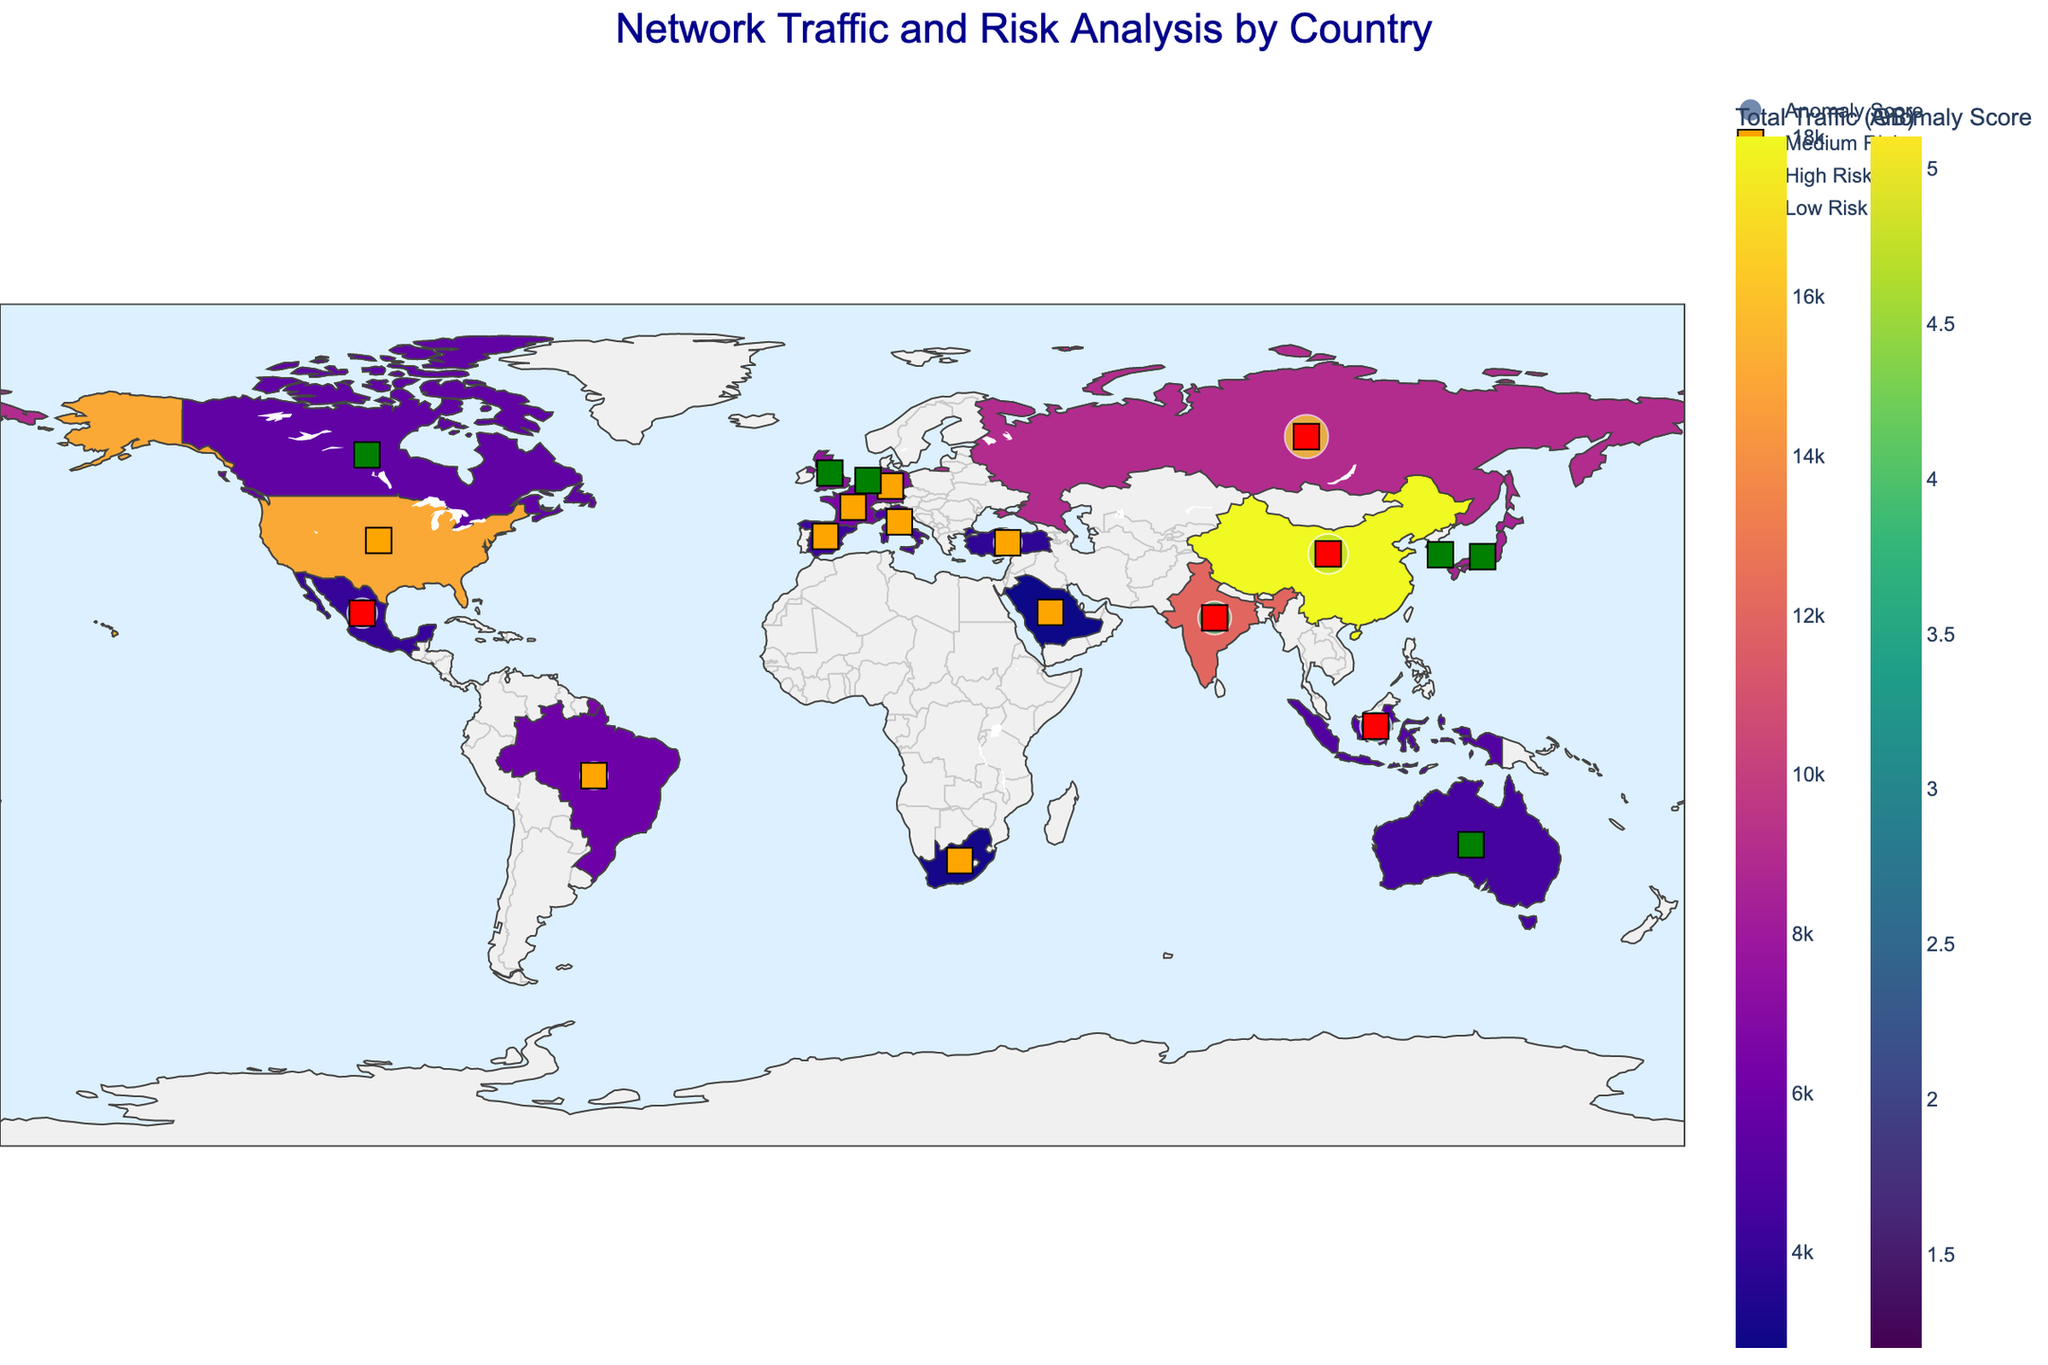What is the title of the figure? The title is typically found at the top of the figure, identifying the contents or purpose of the visual representation. In this case, the title is clearly displayed in dark blue at the center top of the figure.
Answer: Network Traffic and Risk Analysis by Country Which country has the highest total network traffic in GB? By examining the color intensity on the choropleth map, the country with the highest total network traffic will have the most intense color. Additionally, the hover data can confirm the exact traffic amount.
Answer: China What are the different risk levels represented in the figure? The legend at the bottom of the figure indicates the different risk levels by color. Squares in green, orange, and red represent low, medium, and high-risk levels respectively.
Answer: Low, Medium, High How does the anomaly score of Russia compare to that of the United Kingdom? Look at the size and color of the anomaly score markers, and refer to the hover data when the respective countries are highlighted. Russia's anomaly score is larger, indicating a higher value.
Answer: Russia's anomaly score is higher Which country with a high-risk level has the lowest total traffic GB? Examine the colors in the choropleth and refer to the hover data. Only countries marked red (High Risk) should be considered. The country with the lightest color among these will have the lowest total traffic.
Answer: Mexico What is the average anomaly score of all countries marked as high-risk? Identify all countries with a high-risk level (red markers), then sum their anomaly scores and divide by the number of these countries. China: 4.7, Russia: 5.1, India: 3.9, Mexico: 3.5, Indonesia: 3.7. Sum = 20.9, count = 5, average = 20.9 / 5.
Answer: 4.18 How many countries are represented with medium-risk levels? Count the number of orange square markers that indicate a medium-risk level.
Answer: 7 Which country with a low anomaly score still has a medium-risk level, and what might this indicate? Identify countries with medium-risk levels (orange squares) and low anomaly scores. Compare the anomaly scores using the hover data.
Answer: South Africa; It may indicate other factors contributing to risk beyond anomaly score Compare the total traffic (GB) between Germany and Japan. Which one has higher traffic and by how much? Consult the hover data for Germany and Japan individually to find their total traffic, then subtract to find the difference. Germany has 7000 GB, Japan has 8500 GB. Difference = 8500 - 7000.
Answer: Japan by 1500 GB Which country has the smallest anomaly score and what is its risk level? Refer to the anomaly score markers' sizes and colors for the smallest, then check the hover data to confirm the corresponding country and its risk level.
Answer: Australia; Low 